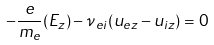Convert formula to latex. <formula><loc_0><loc_0><loc_500><loc_500>- \frac { e } { m _ { e } } ( E _ { z } ) - \nu _ { e i } ( u _ { e z } - u _ { i z } ) = 0</formula> 